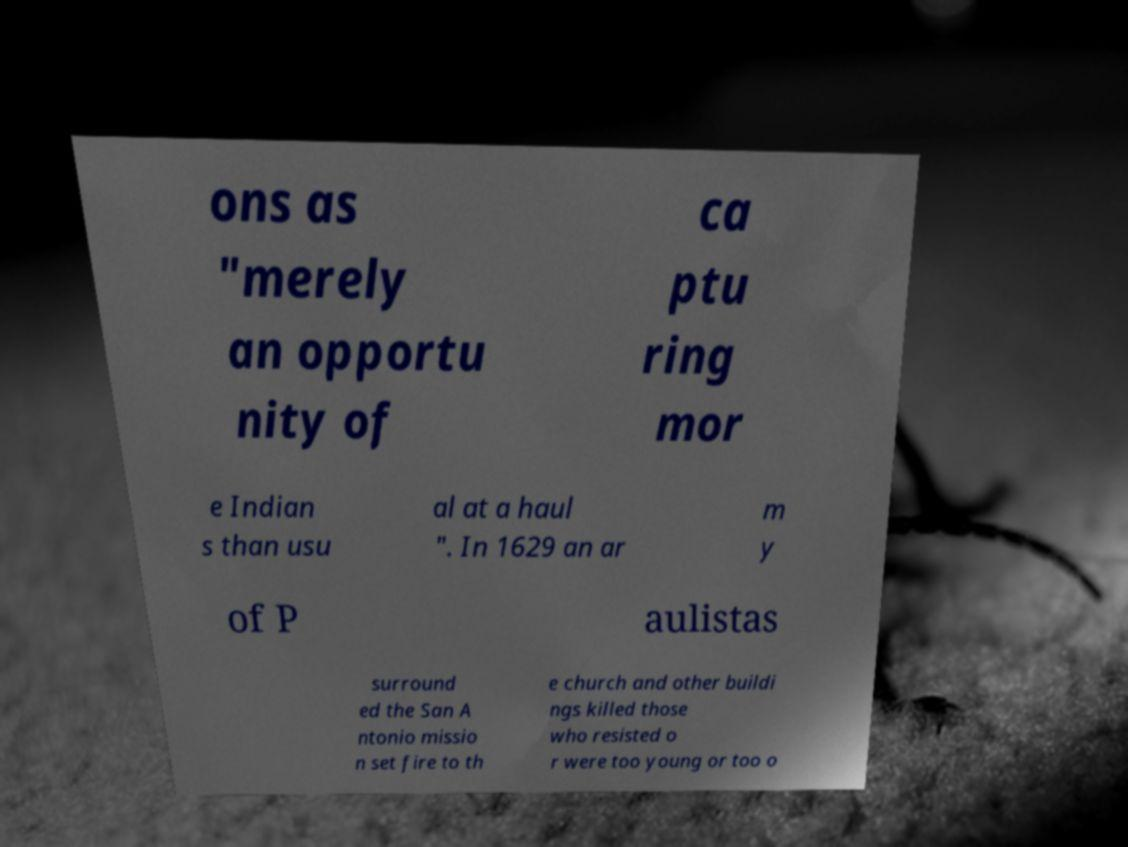There's text embedded in this image that I need extracted. Can you transcribe it verbatim? ons as "merely an opportu nity of ca ptu ring mor e Indian s than usu al at a haul ". In 1629 an ar m y of P aulistas surround ed the San A ntonio missio n set fire to th e church and other buildi ngs killed those who resisted o r were too young or too o 